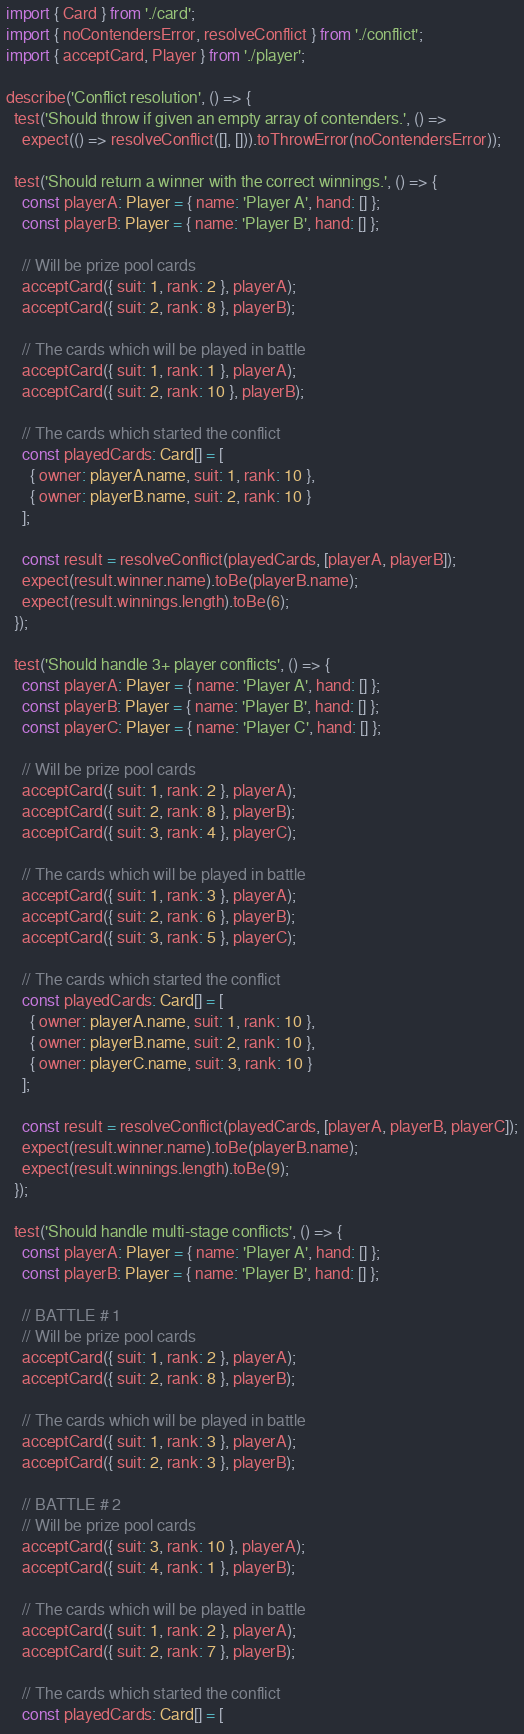<code> <loc_0><loc_0><loc_500><loc_500><_TypeScript_>import { Card } from './card';
import { noContendersError, resolveConflict } from './conflict';
import { acceptCard, Player } from './player';

describe('Conflict resolution', () => {
  test('Should throw if given an empty array of contenders.', () =>
    expect(() => resolveConflict([], [])).toThrowError(noContendersError));

  test('Should return a winner with the correct winnings.', () => {
    const playerA: Player = { name: 'Player A', hand: [] };
    const playerB: Player = { name: 'Player B', hand: [] };

    // Will be prize pool cards
    acceptCard({ suit: 1, rank: 2 }, playerA);
    acceptCard({ suit: 2, rank: 8 }, playerB);

    // The cards which will be played in battle
    acceptCard({ suit: 1, rank: 1 }, playerA);
    acceptCard({ suit: 2, rank: 10 }, playerB);

    // The cards which started the conflict
    const playedCards: Card[] = [
      { owner: playerA.name, suit: 1, rank: 10 },
      { owner: playerB.name, suit: 2, rank: 10 }
    ];

    const result = resolveConflict(playedCards, [playerA, playerB]);
    expect(result.winner.name).toBe(playerB.name);
    expect(result.winnings.length).toBe(6);
  });

  test('Should handle 3+ player conflicts', () => {
    const playerA: Player = { name: 'Player A', hand: [] };
    const playerB: Player = { name: 'Player B', hand: [] };
    const playerC: Player = { name: 'Player C', hand: [] };

    // Will be prize pool cards
    acceptCard({ suit: 1, rank: 2 }, playerA);
    acceptCard({ suit: 2, rank: 8 }, playerB);
    acceptCard({ suit: 3, rank: 4 }, playerC);

    // The cards which will be played in battle
    acceptCard({ suit: 1, rank: 3 }, playerA);
    acceptCard({ suit: 2, rank: 6 }, playerB);
    acceptCard({ suit: 3, rank: 5 }, playerC);

    // The cards which started the conflict
    const playedCards: Card[] = [
      { owner: playerA.name, suit: 1, rank: 10 },
      { owner: playerB.name, suit: 2, rank: 10 },
      { owner: playerC.name, suit: 3, rank: 10 }
    ];

    const result = resolveConflict(playedCards, [playerA, playerB, playerC]);
    expect(result.winner.name).toBe(playerB.name);
    expect(result.winnings.length).toBe(9);
  });

  test('Should handle multi-stage conflicts', () => {
    const playerA: Player = { name: 'Player A', hand: [] };
    const playerB: Player = { name: 'Player B', hand: [] };

    // BATTLE # 1
    // Will be prize pool cards
    acceptCard({ suit: 1, rank: 2 }, playerA);
    acceptCard({ suit: 2, rank: 8 }, playerB);

    // The cards which will be played in battle
    acceptCard({ suit: 1, rank: 3 }, playerA);
    acceptCard({ suit: 2, rank: 3 }, playerB);

    // BATTLE # 2
    // Will be prize pool cards
    acceptCard({ suit: 3, rank: 10 }, playerA);
    acceptCard({ suit: 4, rank: 1 }, playerB);

    // The cards which will be played in battle
    acceptCard({ suit: 1, rank: 2 }, playerA);
    acceptCard({ suit: 2, rank: 7 }, playerB);

    // The cards which started the conflict
    const playedCards: Card[] = [</code> 